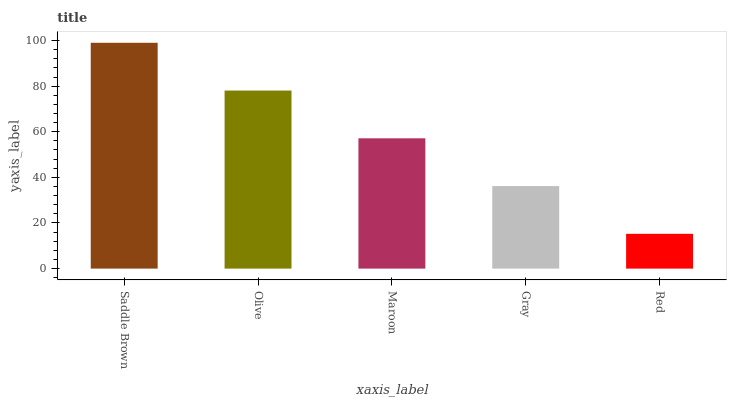Is Red the minimum?
Answer yes or no. Yes. Is Saddle Brown the maximum?
Answer yes or no. Yes. Is Olive the minimum?
Answer yes or no. No. Is Olive the maximum?
Answer yes or no. No. Is Saddle Brown greater than Olive?
Answer yes or no. Yes. Is Olive less than Saddle Brown?
Answer yes or no. Yes. Is Olive greater than Saddle Brown?
Answer yes or no. No. Is Saddle Brown less than Olive?
Answer yes or no. No. Is Maroon the high median?
Answer yes or no. Yes. Is Maroon the low median?
Answer yes or no. Yes. Is Olive the high median?
Answer yes or no. No. Is Olive the low median?
Answer yes or no. No. 